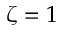Convert formula to latex. <formula><loc_0><loc_0><loc_500><loc_500>\zeta = 1</formula> 